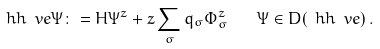Convert formula to latex. <formula><loc_0><loc_0><loc_500><loc_500>\ h h _ { \ } v e \Psi \colon = H \Psi ^ { z } + z \sum _ { \sigma } q _ { \sigma } \Phi _ { \sigma } ^ { z } \quad \Psi \in D ( \ h h _ { \ } v e ) \, .</formula> 